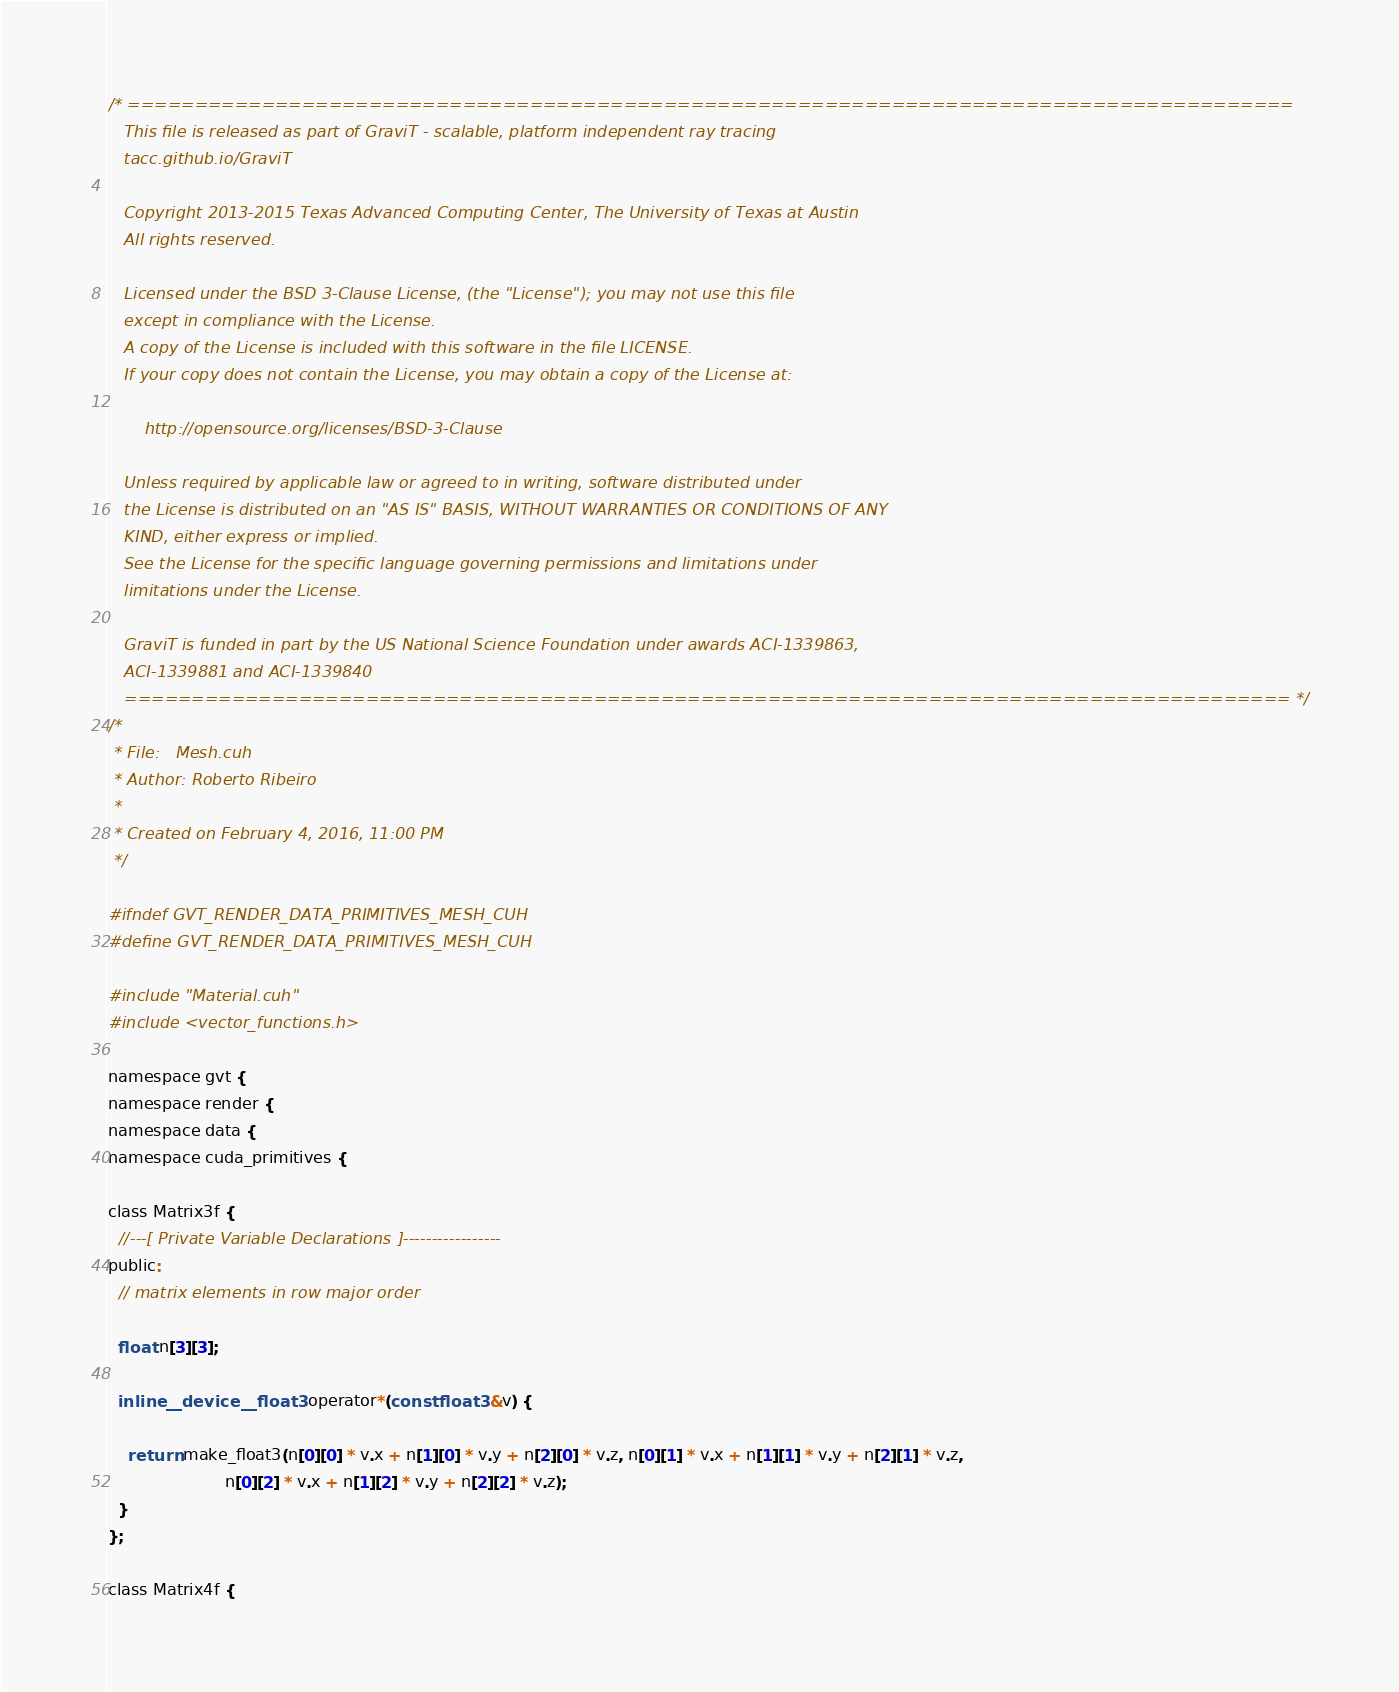Convert code to text. <code><loc_0><loc_0><loc_500><loc_500><_Cuda_>/* =======================================================================================
   This file is released as part of GraviT - scalable, platform independent ray tracing
   tacc.github.io/GraviT

   Copyright 2013-2015 Texas Advanced Computing Center, The University of Texas at Austin
   All rights reserved.

   Licensed under the BSD 3-Clause License, (the "License"); you may not use this file
   except in compliance with the License.
   A copy of the License is included with this software in the file LICENSE.
   If your copy does not contain the License, you may obtain a copy of the License at:

       http://opensource.org/licenses/BSD-3-Clause

   Unless required by applicable law or agreed to in writing, software distributed under
   the License is distributed on an "AS IS" BASIS, WITHOUT WARRANTIES OR CONDITIONS OF ANY
   KIND, either express or implied.
   See the License for the specific language governing permissions and limitations under
   limitations under the License.

   GraviT is funded in part by the US National Science Foundation under awards ACI-1339863,
   ACI-1339881 and ACI-1339840
   ======================================================================================= */
/*
 * File:   Mesh.cuh
 * Author: Roberto Ribeiro
 *
 * Created on February 4, 2016, 11:00 PM
 */

#ifndef GVT_RENDER_DATA_PRIMITIVES_MESH_CUH
#define GVT_RENDER_DATA_PRIMITIVES_MESH_CUH

#include "Material.cuh"
#include <vector_functions.h>

namespace gvt {
namespace render {
namespace data {
namespace cuda_primitives {

class Matrix3f {
  //---[ Private Variable Declarations ]-----------------
public:
  // matrix elements in row major order

  float n[3][3];

  inline __device__ float3 operator*(const float3 &v) {

    return make_float3(n[0][0] * v.x + n[1][0] * v.y + n[2][0] * v.z, n[0][1] * v.x + n[1][1] * v.y + n[2][1] * v.z,
                       n[0][2] * v.x + n[1][2] * v.y + n[2][2] * v.z);
  }
};

class Matrix4f {</code> 